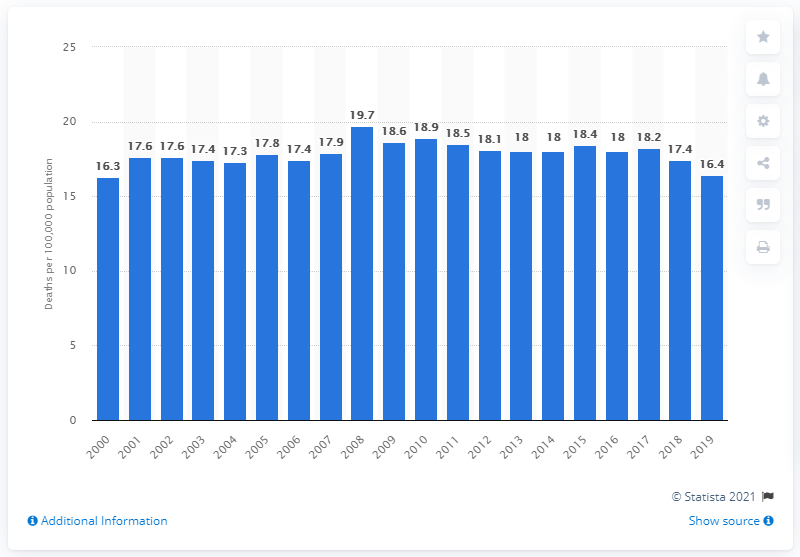Highlight a few significant elements in this photo. In 2000, the death rate per 100,000 Canadians was 16.3. In 2019, the number of Canadians who died from Alzheimer's disease was 16.4. 